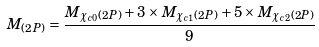Convert formula to latex. <formula><loc_0><loc_0><loc_500><loc_500>M _ { ( 2 P ) } = \frac { M _ { \chi _ { c 0 } ( 2 P ) } + 3 \times M _ { \chi _ { c 1 } ( 2 P ) } + 5 \times M _ { \chi _ { c 2 } ( 2 P ) } } { 9 }</formula> 